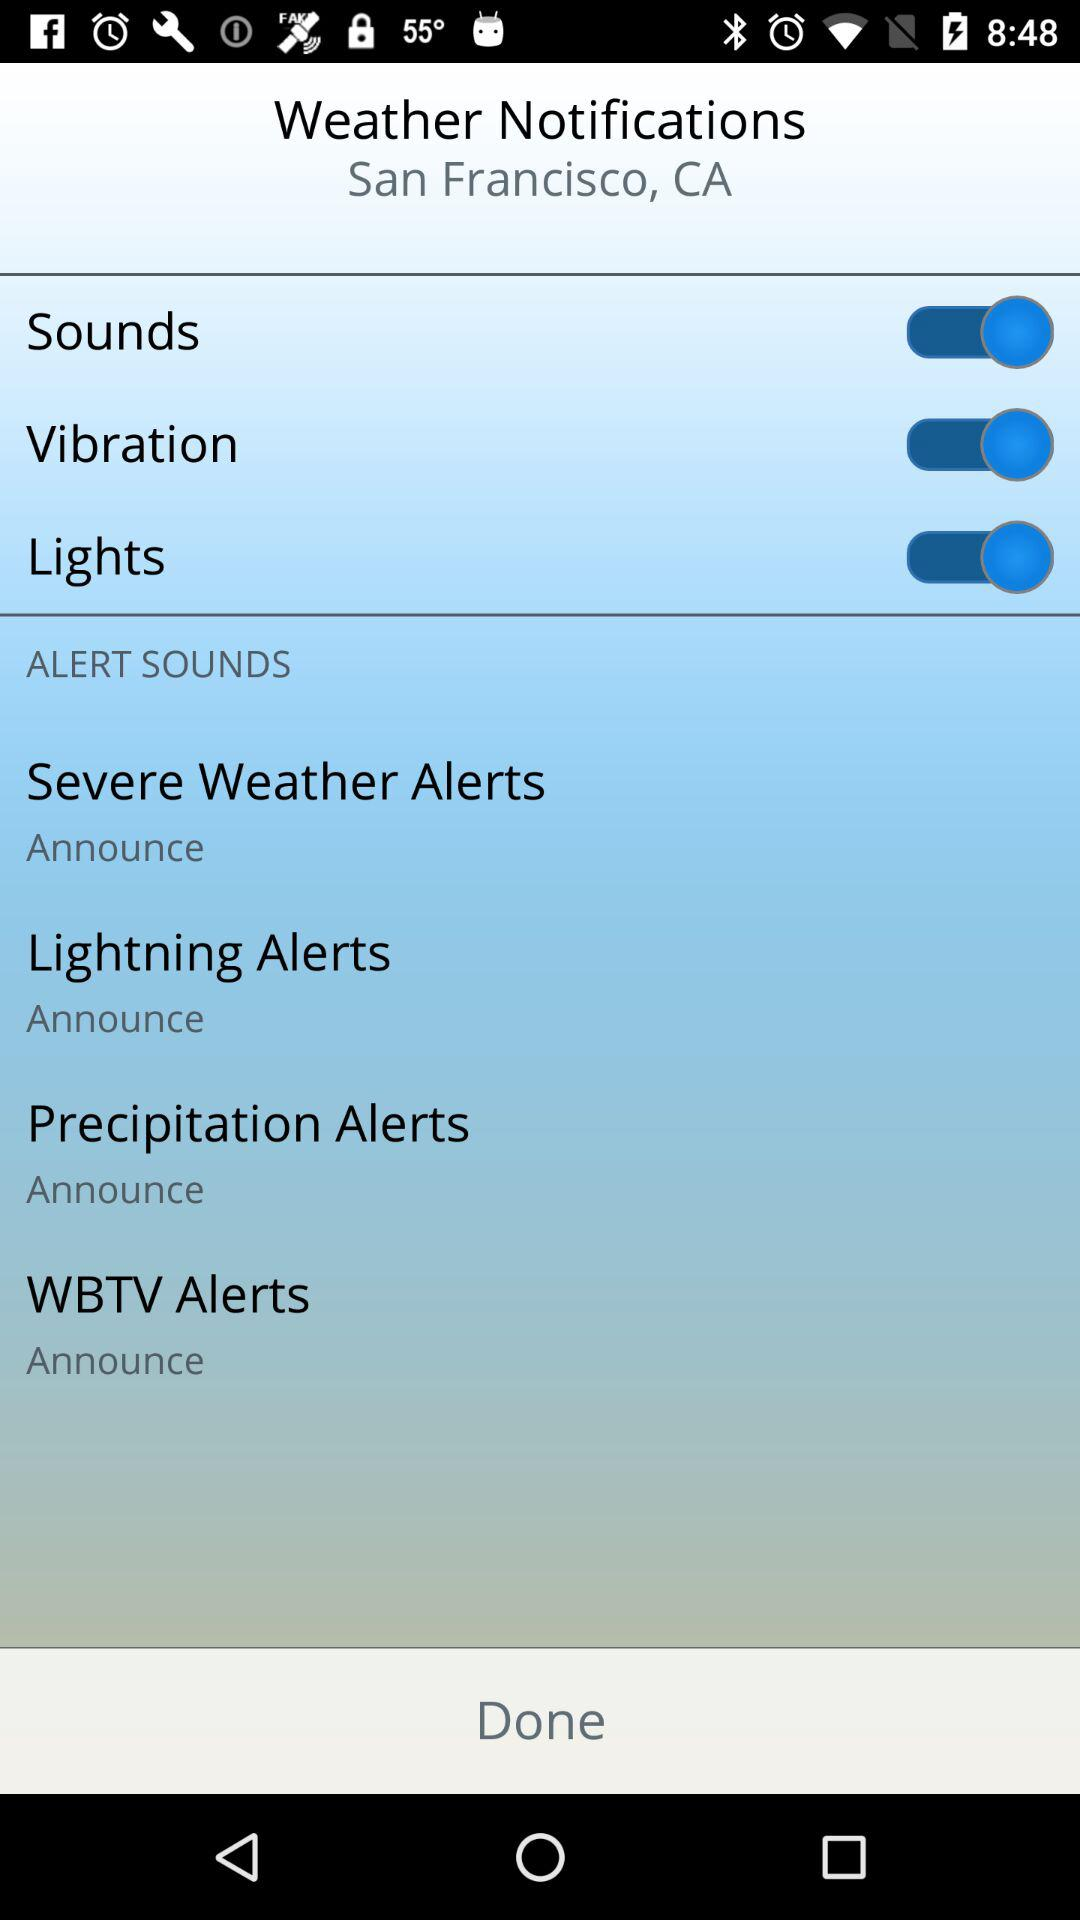What is the status of the "Vibration" setting? The status of the "Vibration" setting is "on". 